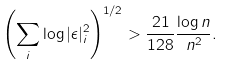<formula> <loc_0><loc_0><loc_500><loc_500>\left ( \sum _ { i } \log | \epsilon | _ { i } ^ { 2 } \right ) ^ { 1 / 2 } > \frac { 2 1 } { 1 2 8 } \frac { \log n } { n ^ { 2 } } .</formula> 